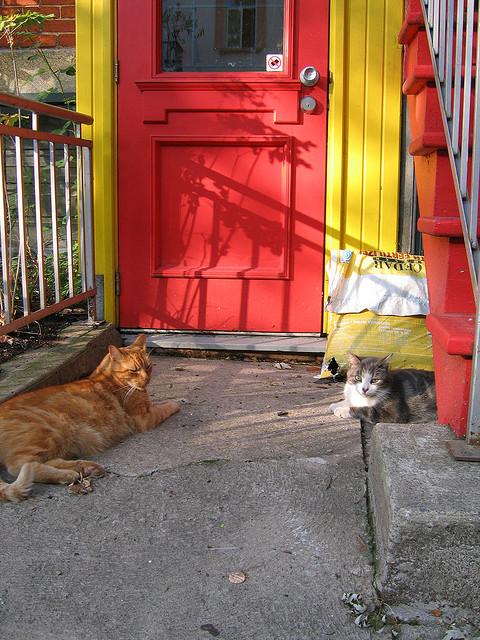Are the cats playing?
Be succinct. No. What color is the door?
Give a very brief answer. Red. Do the cats in this picture look alike?
Answer briefly. No. 